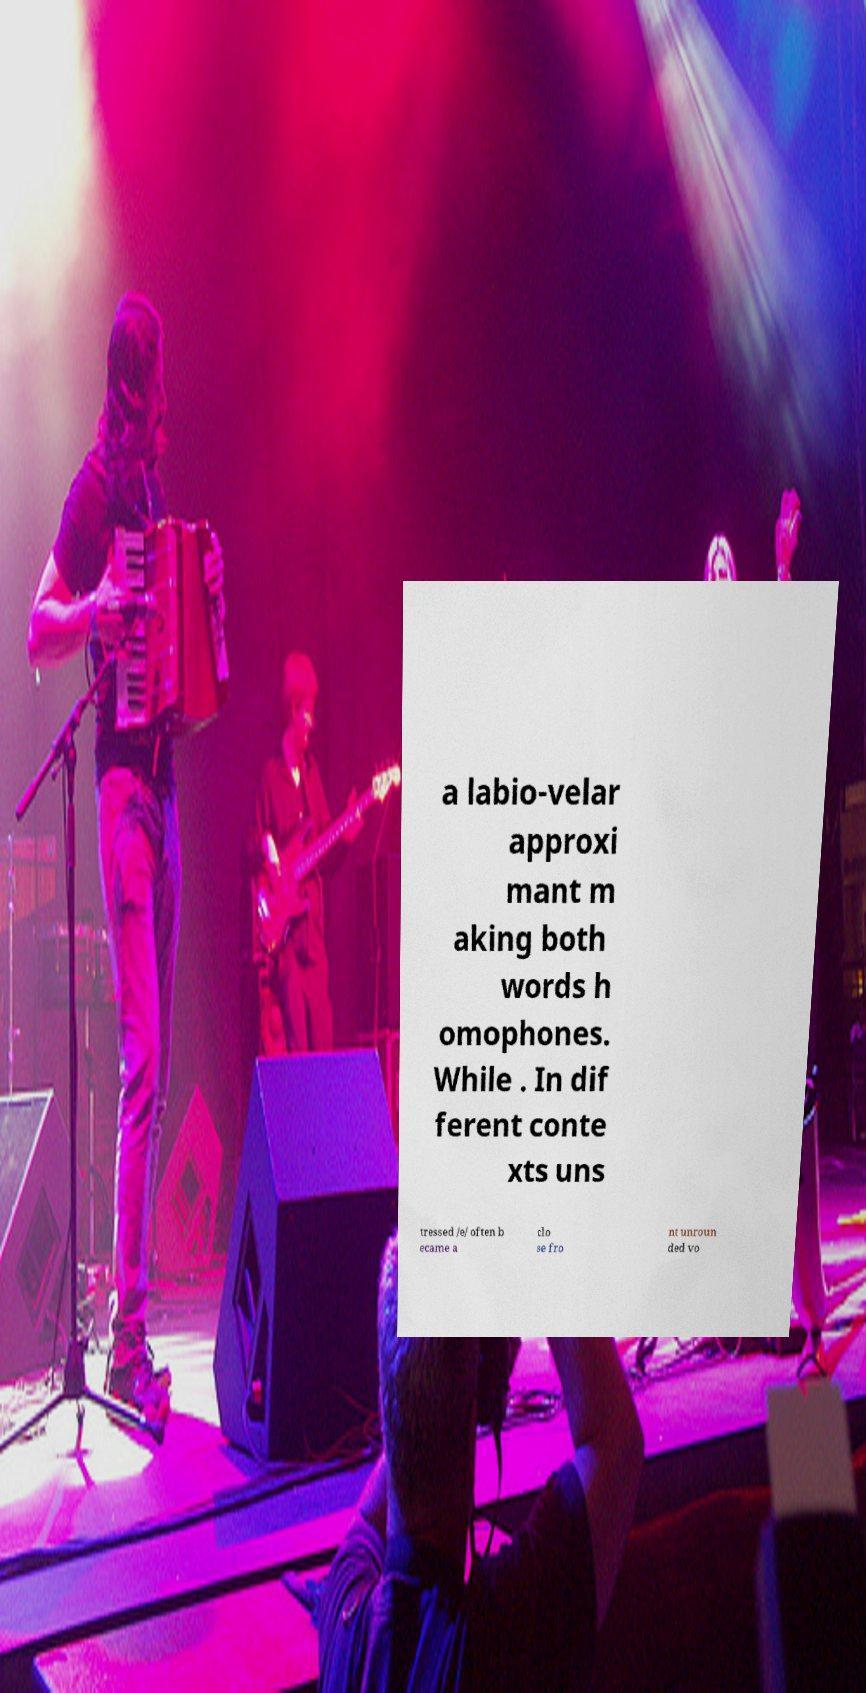Could you extract and type out the text from this image? a labio-velar approxi mant m aking both words h omophones. While . In dif ferent conte xts uns tressed /e/ often b ecame a clo se fro nt unroun ded vo 